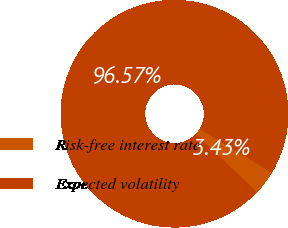Convert chart to OTSL. <chart><loc_0><loc_0><loc_500><loc_500><pie_chart><fcel>Risk-free interest rate<fcel>Expected volatility<nl><fcel>3.43%<fcel>96.57%<nl></chart> 